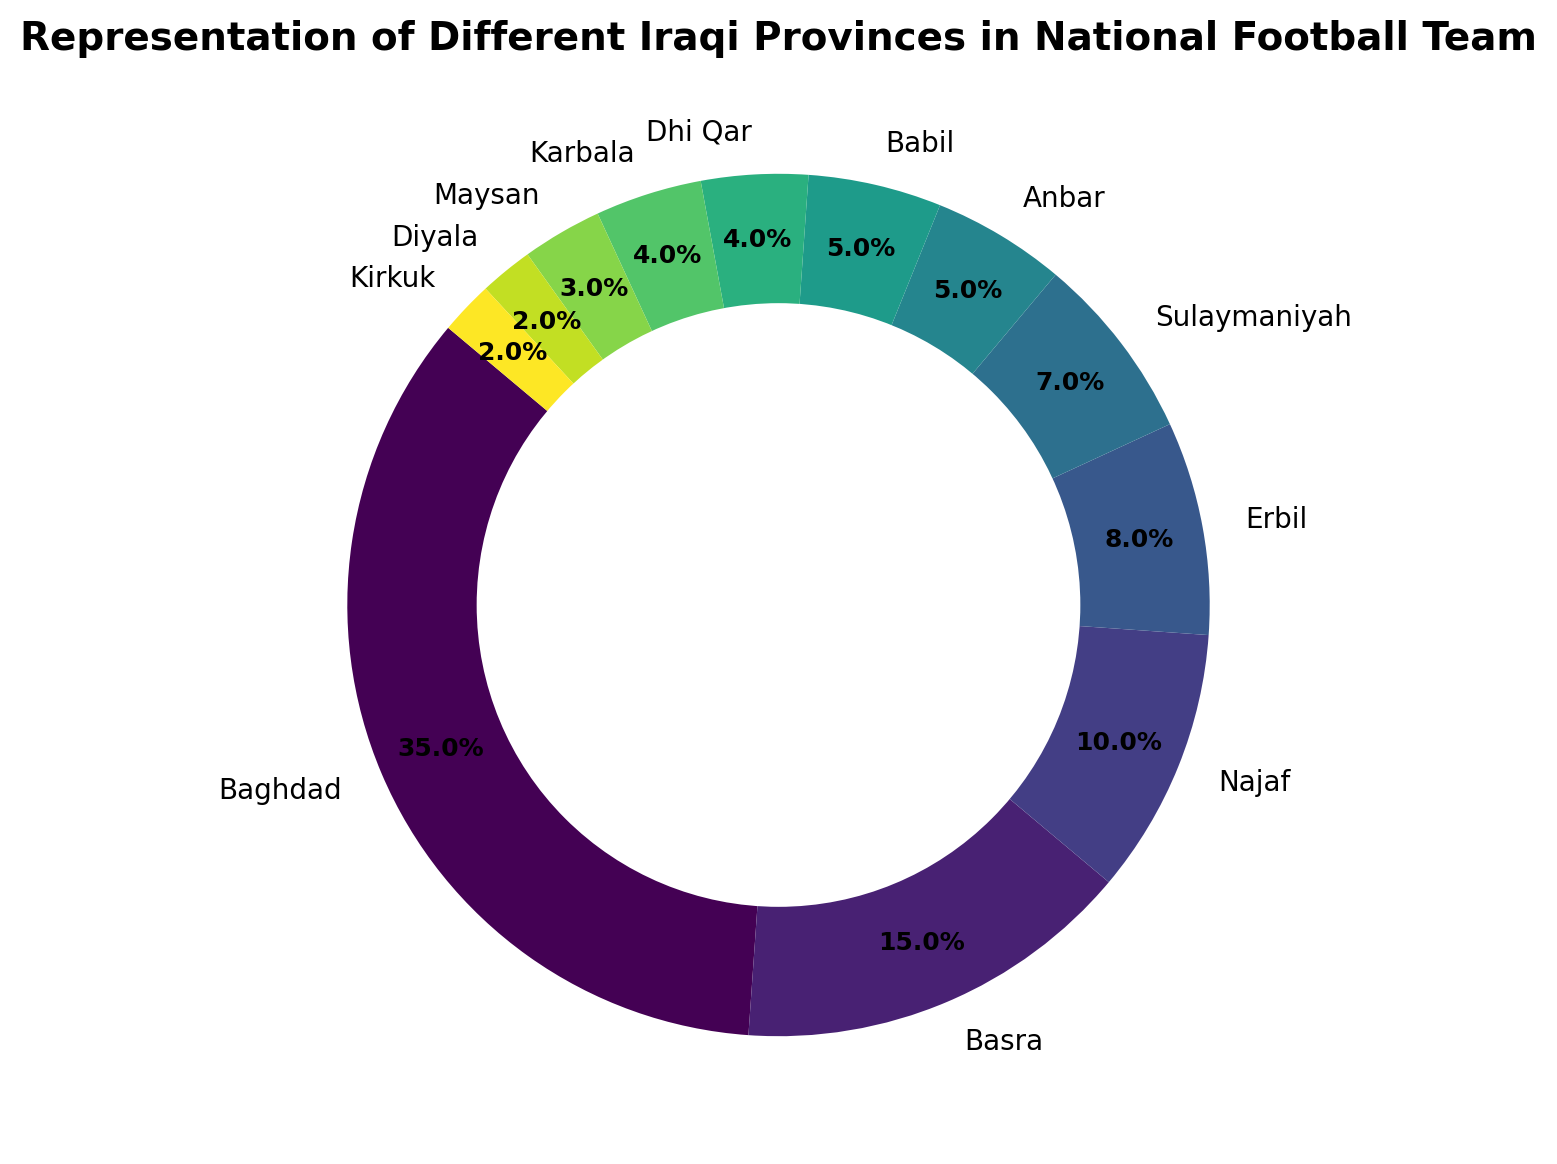Which province has the highest representation in the national football team? Baghdad has the highest percentage of representation at 35%. This can be seen as it has the largest slice in the pie chart.
Answer: Baghdad What is the total representation percentage of Basra, Najaf, and Erbil combined? The percentages for Basra, Najaf, and Erbil are 15%, 10%, and 8% respectively. Adding these together gives 15 + 10 + 8 = 33%.
Answer: 33% Which provinces have the smallest representation and what are their combined percentage? The provinces with the smallest representation are Diyala and Kirkuk, each with 2%. Combined, their percentage is 2 + 2 = 4%.
Answer: Diyala and Kirkuk, 4% Between Basra and Baghdad, which province has a higher representation and by how much? Baghdad has a representation of 35% and Basra has 15%. The difference is 35 - 15 = 20%.
Answer: Baghdad, 20% How many provinces have a representation percentage less than 5%? The provinces with less than 5% are Dhi Qar, Karbala, Maysan, Diyala, and Kirkuk. There are 5 provinces in total with less than 5% representation.
Answer: 5 What is the representation percentage of the three provinces with the smallest representation combined? The three provinces with the smallest representation are Maysan, Diyala, and Kirkuk with 3%, 2%, and 2% respectively. Adding these together gives 3 + 2 + 2 = 7%.
Answer: 7% Which province has a larger representation, Sulaymaniyah or Najaf, and by how much? Najaf has a representation of 10% and Sulaymaniyah has 7%. The difference is 10 - 7 = 3%.
Answer: Najaf, 3% What is the combined representation percentage of the provinces from the Kurdistan region (Erbil, Sulaymaniyah, and Duhok)? From the data given, the provinces from the Kurdistan region with representation are Erbil (8%) and Sulaymaniyah (7%). Combining these gives 8 + 7 = 15%. Duhok is not listed, so it is assumed to have 0% representation.
Answer: 15% Which province has a representation percentage closest to the average representation of all provinces? The total representation percentage is 100%, and there are 12 provinces, giving an average of 100/12 ≈ 8.33%. Erbil, with an 8% representation, is closest to this average.
Answer: Erbil, 8% How does the representation of Babil compare to that of Anbar? Babil and Anbar each has a representation of 5%. Thus, their representations are equal.
Answer: Equal, 5% 